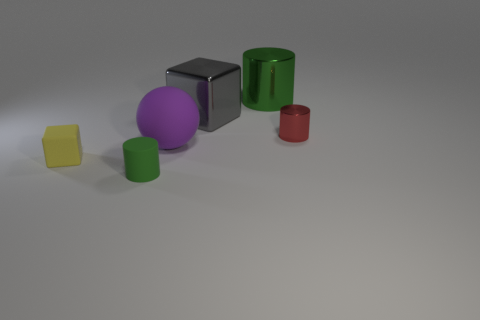Subtract all green cylinders. How many were subtracted if there are1green cylinders left? 1 Subtract all yellow cylinders. Subtract all cyan blocks. How many cylinders are left? 3 Add 3 large gray rubber objects. How many objects exist? 9 Subtract all spheres. How many objects are left? 5 Subtract 0 gray spheres. How many objects are left? 6 Subtract all green matte cylinders. Subtract all big objects. How many objects are left? 2 Add 4 green metal cylinders. How many green metal cylinders are left? 5 Add 5 large blue shiny cylinders. How many large blue shiny cylinders exist? 5 